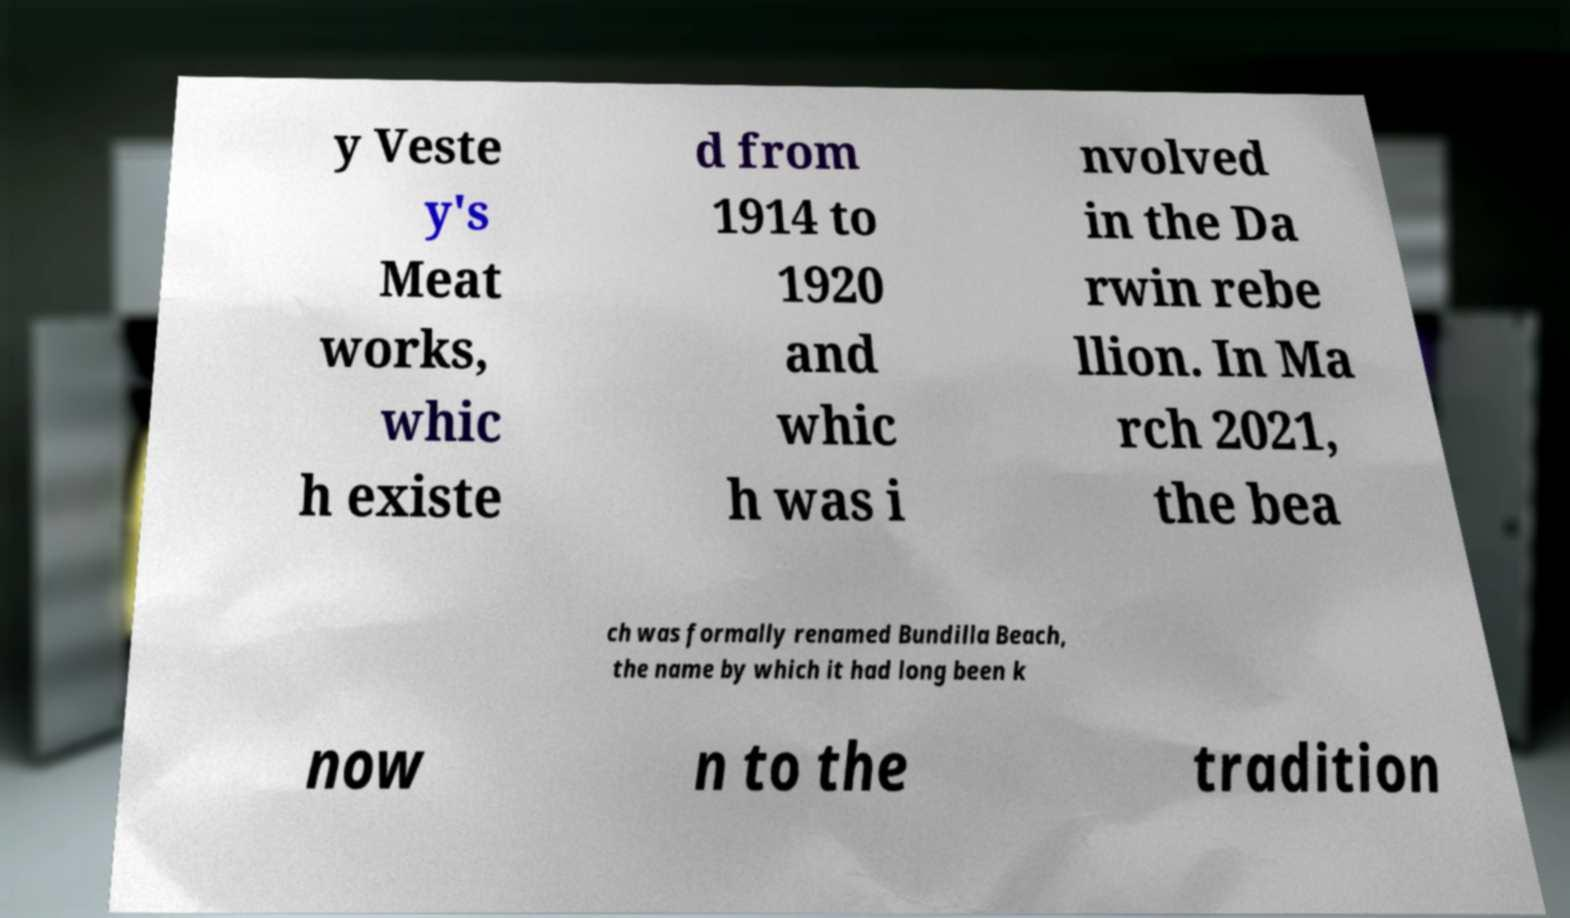Please identify and transcribe the text found in this image. y Veste y's Meat works, whic h existe d from 1914 to 1920 and whic h was i nvolved in the Da rwin rebe llion. In Ma rch 2021, the bea ch was formally renamed Bundilla Beach, the name by which it had long been k now n to the tradition 